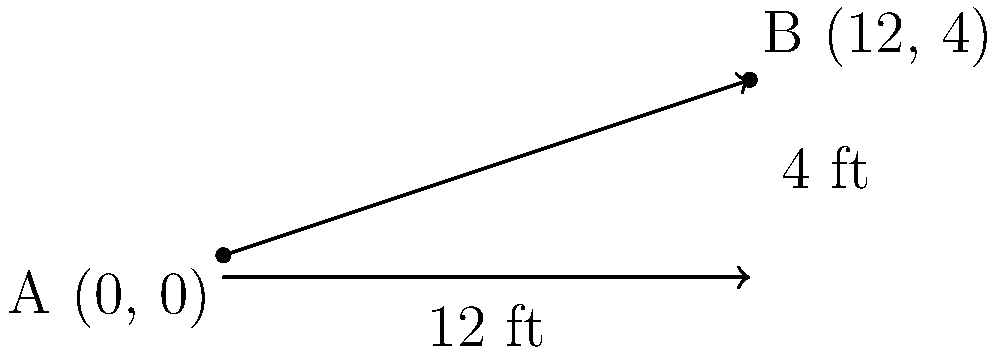As a construction company owner, you're working on a new house project. The roof edge runs from point A (0, 0) to point B (12, 4), where the horizontal distance is in feet. What's the slope of this roof edge? Express your answer as a ratio in its simplest form. To find the slope of the roof edge, we'll use the slope formula:

$$ \text{Slope} = \frac{\text{Rise}}{\text{Run}} = \frac{y_2 - y_1}{x_2 - x_1} $$

Given:
- Point A: (0, 0)
- Point B: (12, 4)

Step 1: Identify the coordinates
$x_1 = 0$, $y_1 = 0$
$x_2 = 12$, $y_2 = 4$

Step 2: Calculate the rise (vertical change)
Rise $= y_2 - y_1 = 4 - 0 = 4$ feet

Step 3: Calculate the run (horizontal change)
Run $= x_2 - x_1 = 12 - 0 = 12$ feet

Step 4: Apply the slope formula
$$ \text{Slope} = \frac{\text{Rise}}{\text{Run}} = \frac{4}{12} $$

Step 5: Simplify the fraction
$\frac{4}{12}$ can be reduced by dividing both the numerator and denominator by their greatest common factor, which is 4:

$$ \frac{4 \div 4}{12 \div 4} = \frac{1}{3} $$

Therefore, the slope of the roof edge is 1:3 or $\frac{1}{3}$.
Answer: 1:3 